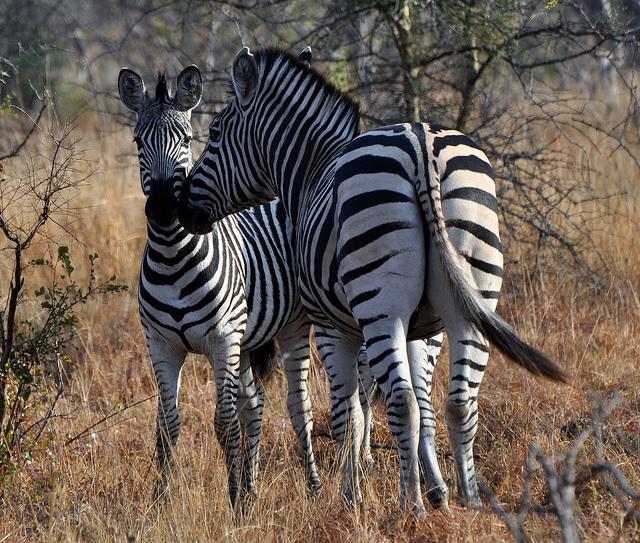Do the animals appear to be aggressive to each other?
Write a very short answer. No. How many zebra are standing together?
Quick response, please. 2. How many zebras are in the picture?
Give a very brief answer. 2. What are the zebras eating?
Write a very short answer. Grass. Are both these zebras facing the same way?
Give a very brief answer. No. How many zebras are in the foreground?
Concise answer only. 2. What type of animals are they?
Write a very short answer. Zebra. How many zebras are there?
Keep it brief. 2. 